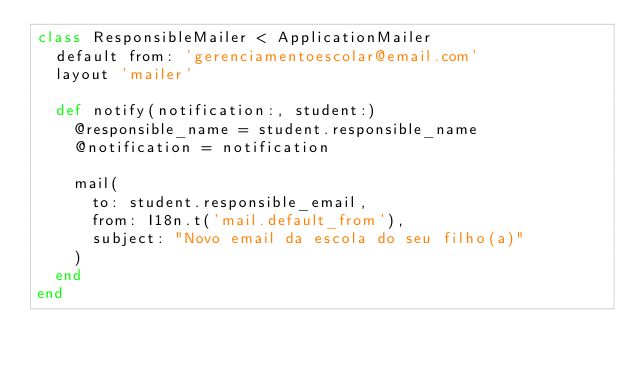<code> <loc_0><loc_0><loc_500><loc_500><_Ruby_>class ResponsibleMailer < ApplicationMailer
  default from: 'gerenciamentoescolar@email.com'
  layout 'mailer'

  def notify(notification:, student:)
    @responsible_name = student.responsible_name
    @notification = notification

    mail(
      to: student.responsible_email,
      from: I18n.t('mail.default_from'),
      subject: "Novo email da escola do seu filho(a)"
    )
  end
end
</code> 